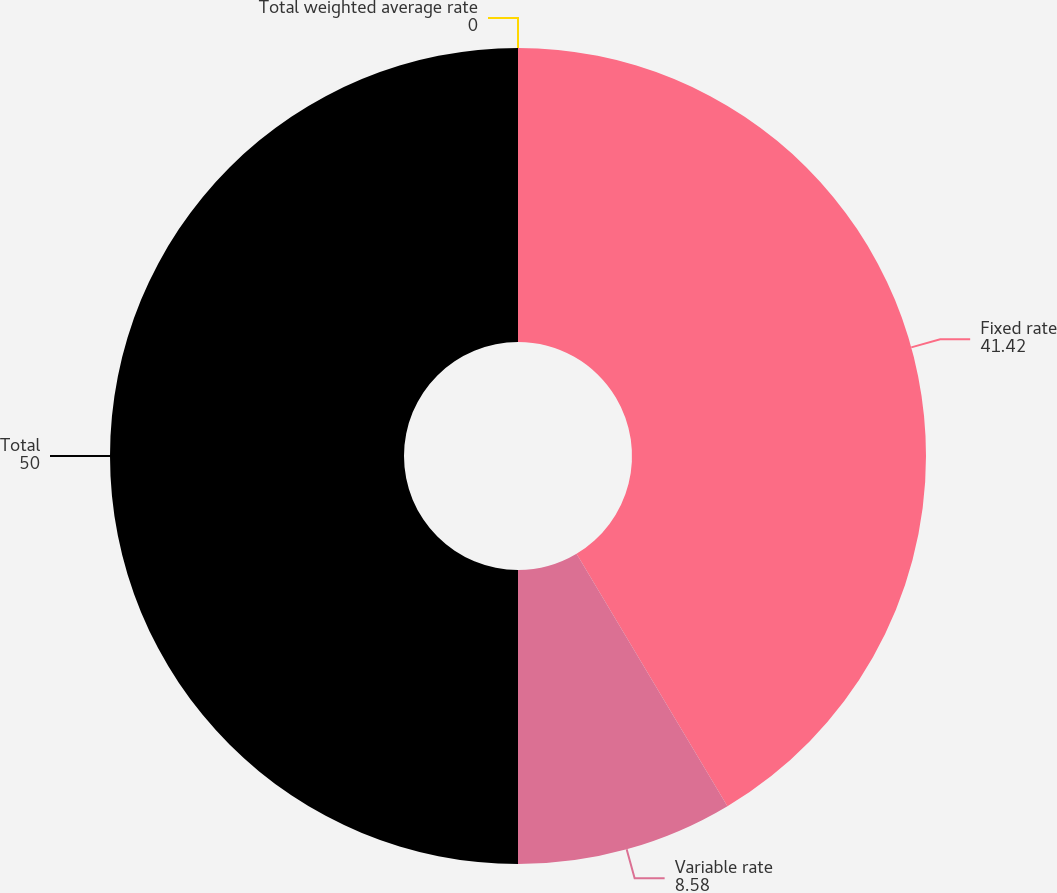Convert chart to OTSL. <chart><loc_0><loc_0><loc_500><loc_500><pie_chart><fcel>Fixed rate<fcel>Variable rate<fcel>Total<fcel>Total weighted average rate<nl><fcel>41.42%<fcel>8.58%<fcel>50.0%<fcel>0.0%<nl></chart> 